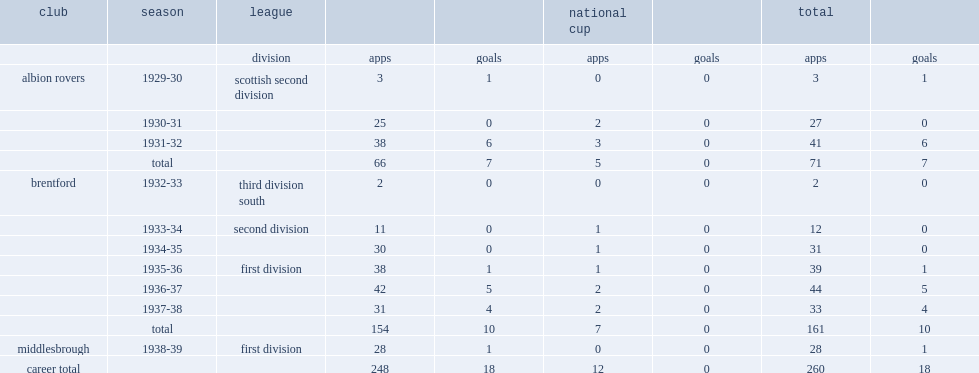How many appearances did mckenzie make during his six years? 161.0. How many goals did mckenzie score during his six years? 10.0. 